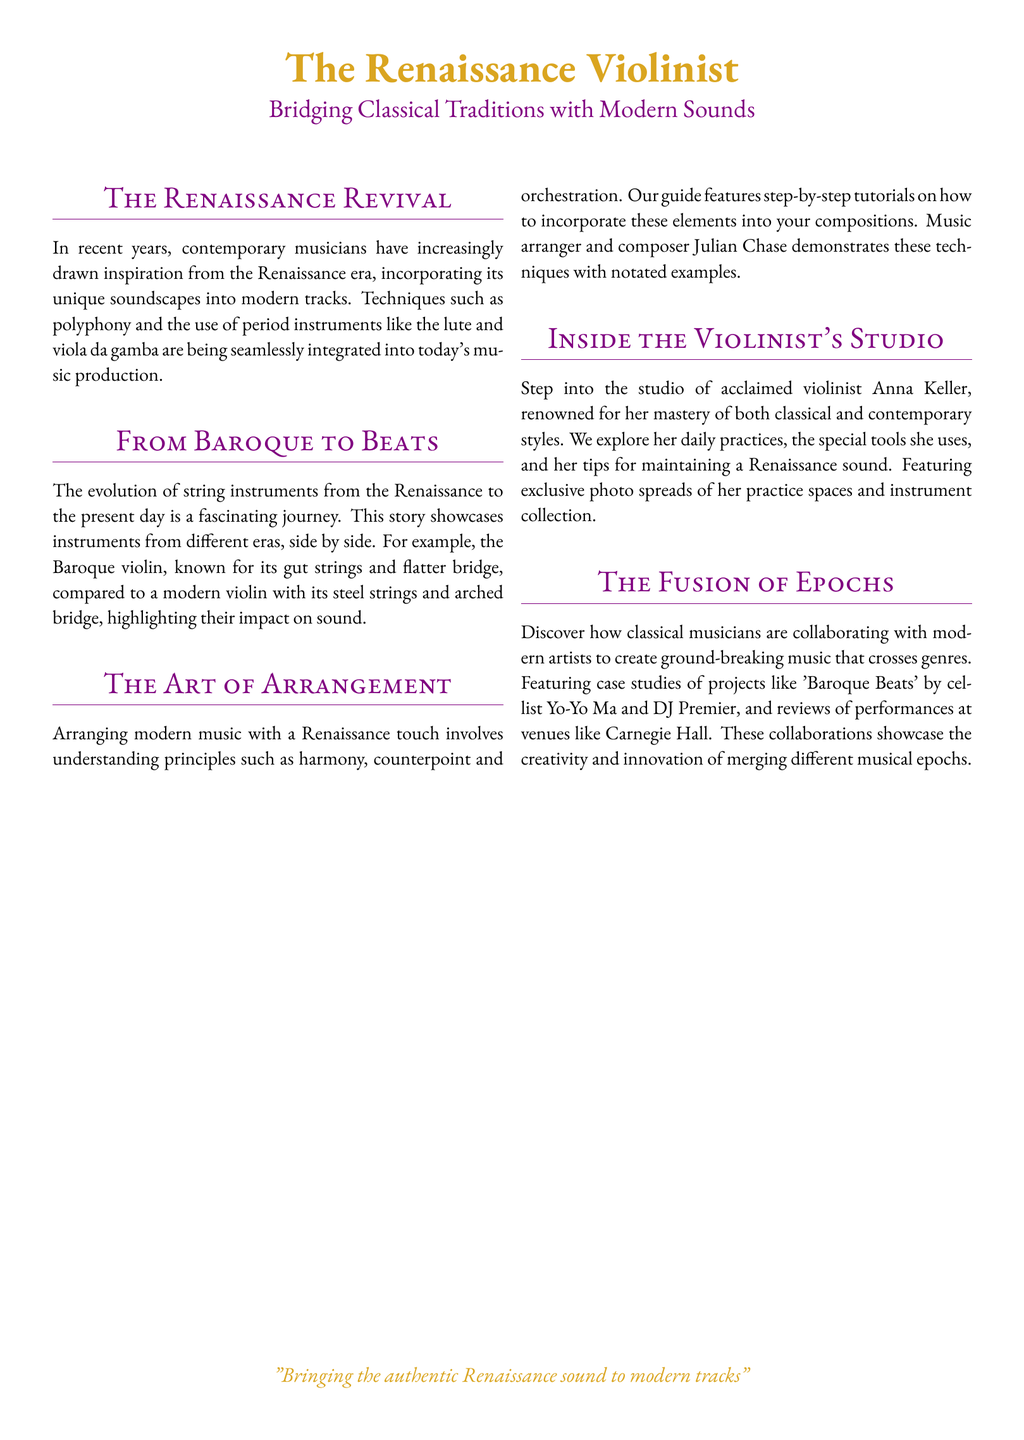What is the title of the magazine? The title of the magazine is presented at the top of the document.
Answer: The Renaissance Violinist What color is used for the main title? The color of the main title can be found in the document's formatting.
Answer: Renaissance Gold Who is highlighted in "Inside the Violinist's Studio"? This person is mentioned in the studio section as a renowned violinist.
Answer: Anna Keller What is the primary focus of "The Fusion of Epochs"? This section deals with collaborations between two music categories.
Answer: Classical musicians and modern artists Which instrument is compared to the modern violin in "From Baroque to Beats"? The historical instrument being compared is stated in that section.
Answer: Baroque violin Who is featured in "The Art of Arrangement"? This individual is mentioned as a music arranger and composer in the arrangement section.
Answer: Julian Chase What musical era is emphasized in "The Renaissance Revival"? This era is identified as the main influence in this section of the document.
Answer: Renaissance What style of music is explored in the magazine? The overall theme of the magazine highlights a specific fusion of styles.
Answer: Contemporary classical music 